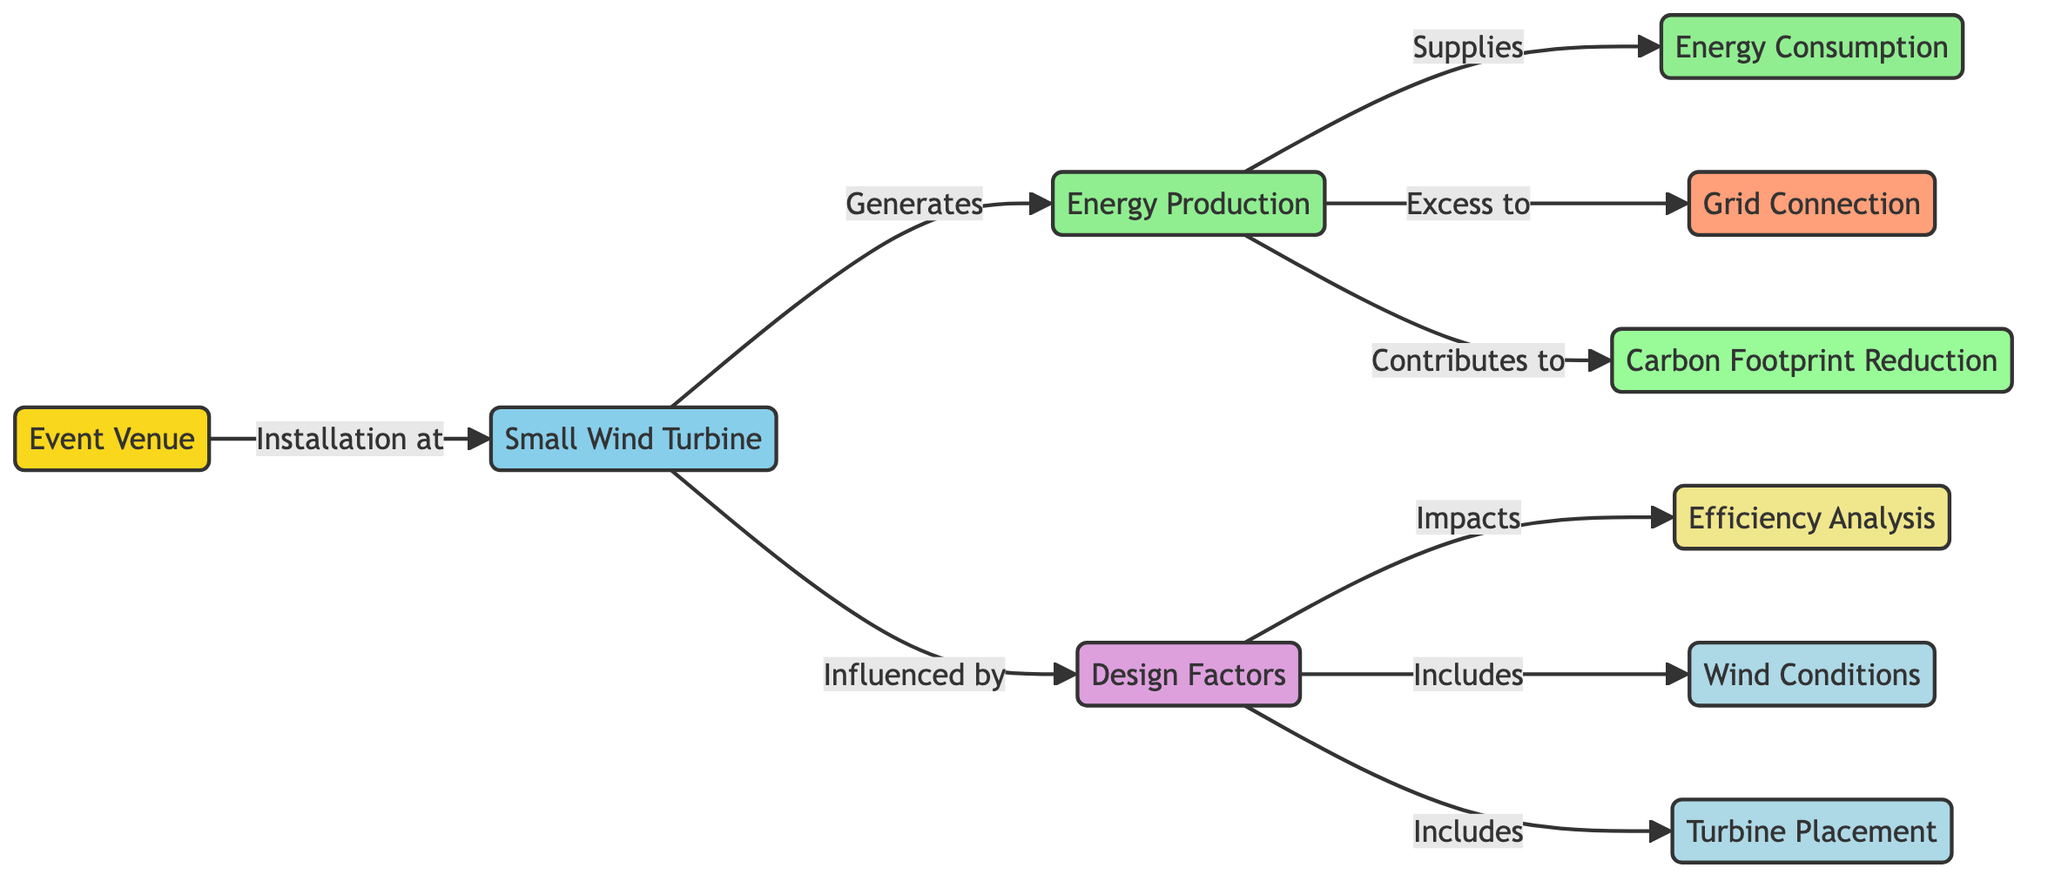what is the primary component installed at the event venue? The diagram indicates that the primary component installed at the event venue is the "Small Wind Turbine." This is the node directly linked to the "Event Venue" node, showing that the installation is at this location.
Answer: Small Wind Turbine how does energy production relate to carbon footprint reduction? The diagram shows that "Energy Production" contributes to "Carbon Footprint Reduction." This means the energy generated from the wind turbine positively impacts reducing carbon emissions associated with the venue's energy use.
Answer: Contributes to how many design factors influence the small wind turbine? The diagram indicates there is a single node titled "Design Factors" that influences the "Small Wind Turbine." This node is directly linked to the wind turbine, signifying its role in system design.
Answer: One what are the two components connected to energy production? From the diagram, "Energy Production" is connected to two components: "Energy Consumption" and "Grid Connection," showing the pathways for energy utilization and surplus energy transfer.
Answer: Energy Consumption and Grid Connection what elements are included in design factors? The diagram lists two elements under "Design Factors": "Wind Conditions" and "Turbine Placement." Both are essential considerations that impact the design and efficiency of the wind turbine system.
Answer: Wind Conditions and Turbine Placement how does turbine placement impact efficiency analysis? The diagram illustrates that "Turbine Placement" is included in the "Design Factors," which then impacts the "Efficiency Analysis." This shows a direct relationship where the placement of the turbine can influence its overall effectiveness.
Answer: Impacts what is the link between grid connection and energy production? The diagram specifies that "Energy Production" supplies excess energy to the "Grid Connection." This shows a direct flow of energy that can be transmitted to the wider electrical grid from the production at the venue.
Answer: Supplies which node is influenced by wind conditions? The "Efficiency Analysis" node is influenced by "Wind Conditions." The flow is established in the diagram to highlight that wind conditions play a crucial role in determining how effectively the turbine can operate.
Answer: Efficiency Analysis what color is used to represent carbon footprint reduction in the diagram? In the diagram, "Carbon Footprint Reduction" is represented using a light green color (hex code #98fb98). This color distinction helps visually categorize the node related to environmental impact.
Answer: Light green 